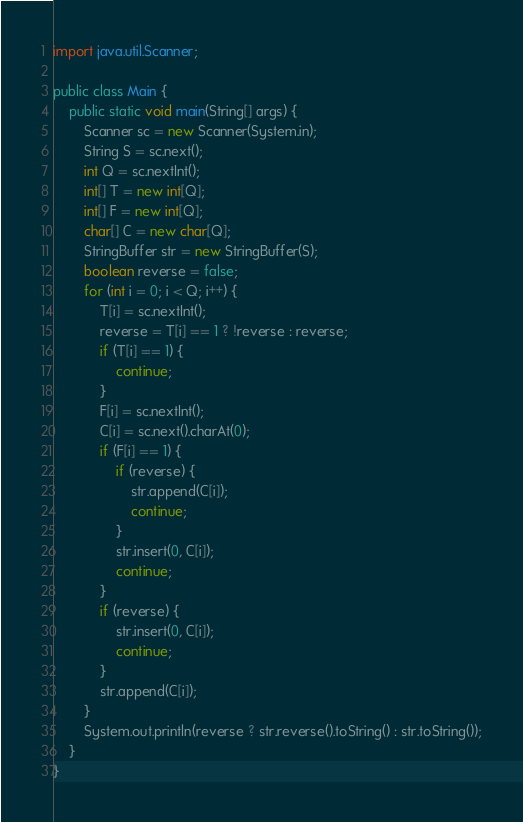<code> <loc_0><loc_0><loc_500><loc_500><_Java_>import java.util.Scanner;

public class Main {
    public static void main(String[] args) {
        Scanner sc = new Scanner(System.in);
        String S = sc.next();
        int Q = sc.nextInt();
        int[] T = new int[Q];
        int[] F = new int[Q];
        char[] C = new char[Q];
        StringBuffer str = new StringBuffer(S);
        boolean reverse = false;
        for (int i = 0; i < Q; i++) {
            T[i] = sc.nextInt();
            reverse = T[i] == 1 ? !reverse : reverse;
            if (T[i] == 1) {
                continue;
            }
            F[i] = sc.nextInt();
            C[i] = sc.next().charAt(0);
            if (F[i] == 1) {
                if (reverse) {
                    str.append(C[i]);
                    continue;
                }
                str.insert(0, C[i]);
                continue;
            }
            if (reverse) {
                str.insert(0, C[i]);
                continue;
            }
            str.append(C[i]);
        }
        System.out.println(reverse ? str.reverse().toString() : str.toString());
    }
}</code> 